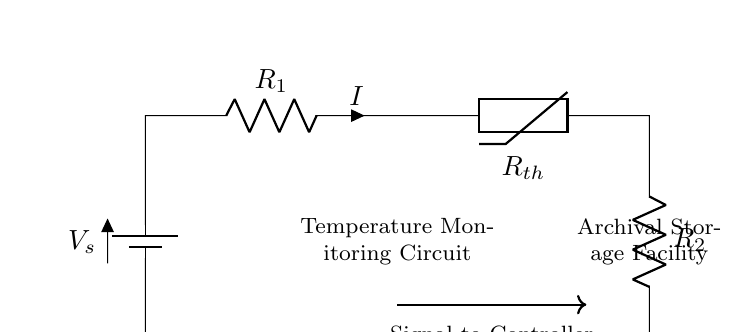What is the type of the first component? The first component in the circuit is a battery, indicated by the notation used. It provides the supplied voltage for the circuit.
Answer: Battery What is the role of the thermistor in this circuit? The thermistor is a temperature-sensitive resistor that changes resistance with temperature variations. Its resistance affects the overall current flow, enabling temperature monitoring.
Answer: Temperature sensing What is the current direction in the circuit? Current flows from the positive terminal of the battery through the components and returns to the battery's negative terminal. This flow can be inferred from the direction of the arrows in the circuit symbol.
Answer: Clockwise What is the total resistance when the thermistor is at low temperature? At low temperatures, the thermistor has a high resistance, while the series resistors combine with it. Without specific values, the total resistance can be considered the sum of the resistors and thermistor at that low state.
Answer: High How can the voltage across the thermistor be calculated? The voltage across the thermistor can be calculated using Ohm's law, along with the resistances of the thermistor and the other resistors in series. This requires knowing the values of each component and the total voltage.
Answer: V = I * R_th What type of circuit is depicted in this diagram? The circuit is a series circuit, where all components are connected one after another, and the same current flows through each component. This arrangement is confirmed by the connections shown in the diagram.
Answer: Series circuit What does the signal to the controller indicate? The signal to the controller indicates that there is a current flow through the thermistor and the resistors, which can be correlated with temperature readings taken from the thermistor. This signal can be transmitted for monitoring purposes.
Answer: Temperature data 